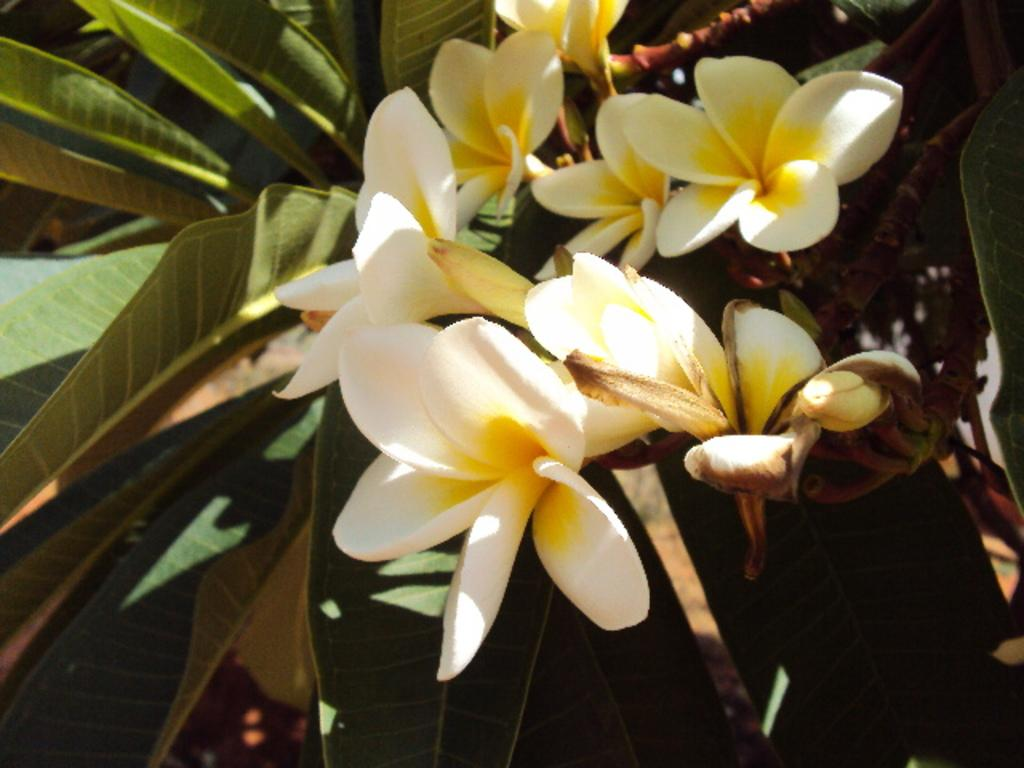What type of plant can be seen in the image? There is a tree in the image. What additional floral elements are visible in the image? There are flowers visible in the image. What can be seen in the background of the image? There are leaves in the background of the image. What type of kite can be seen flying in the image? There is no kite present in the image; it features a tree, flowers, and leaves. What industry is depicted in the image? There is no industry depicted in the image; it focuses on natural elements such as a tree, flowers, and leaves. 